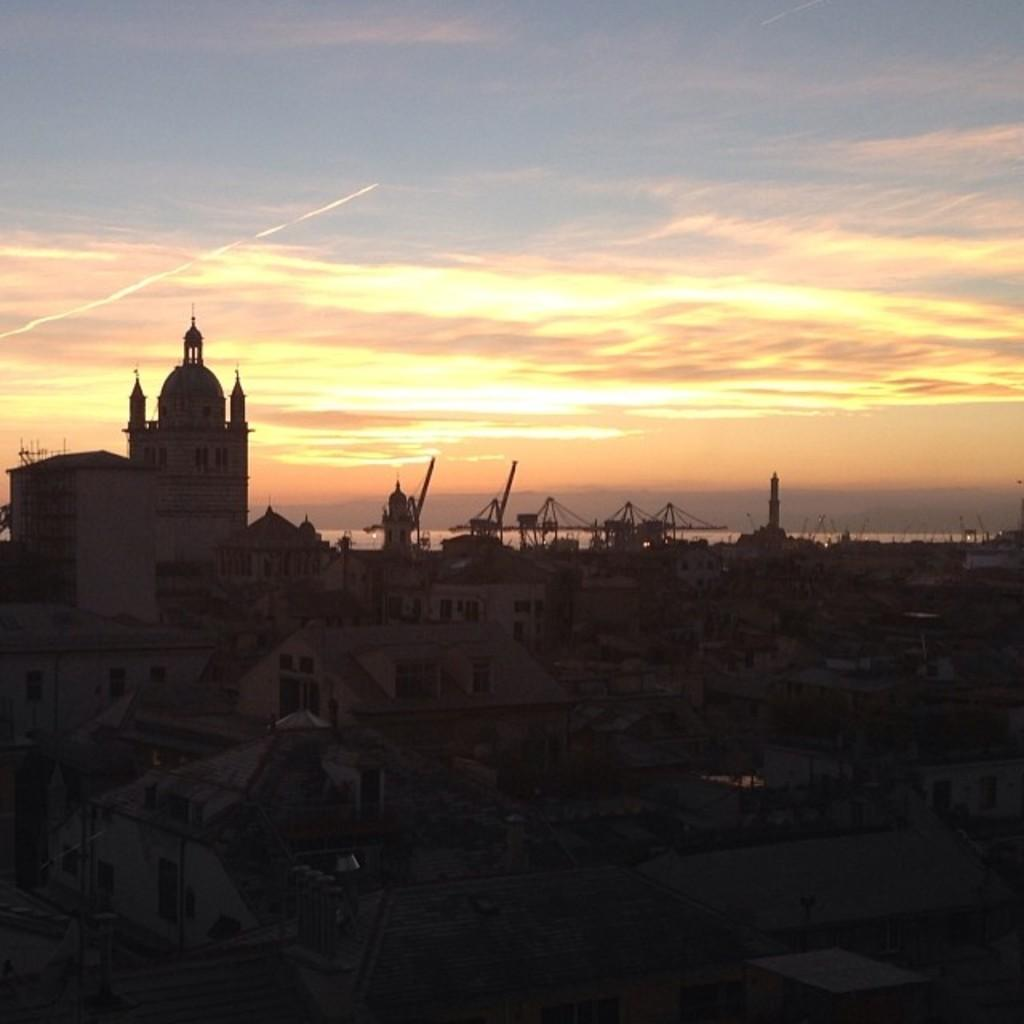What structures can be seen in the image? There are buildings in the image. What part of the natural environment is visible in the image? The sky is visible in the background of the image. Can you tell me how many snails are crawling on the buildings in the image? There are no snails present in the image; it only features buildings and the sky. What type of story is being told in the image? The image does not depict a story; it is a static representation of buildings and the sky. 